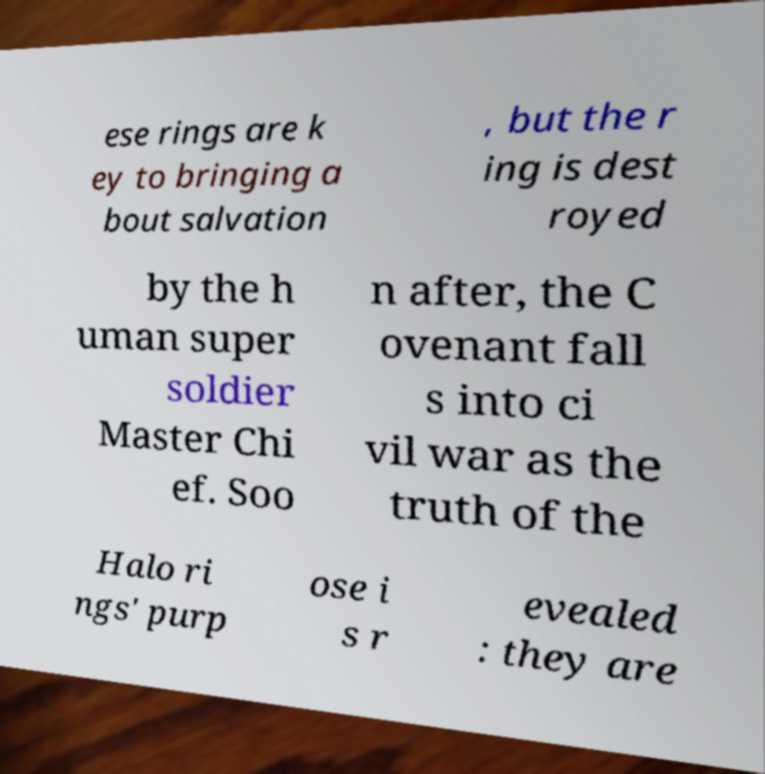Can you accurately transcribe the text from the provided image for me? ese rings are k ey to bringing a bout salvation , but the r ing is dest royed by the h uman super soldier Master Chi ef. Soo n after, the C ovenant fall s into ci vil war as the truth of the Halo ri ngs' purp ose i s r evealed : they are 